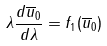Convert formula to latex. <formula><loc_0><loc_0><loc_500><loc_500>\lambda \frac { d \overline { u } _ { 0 } } { d \lambda } = f _ { 1 } ( \overline { u } _ { 0 } )</formula> 